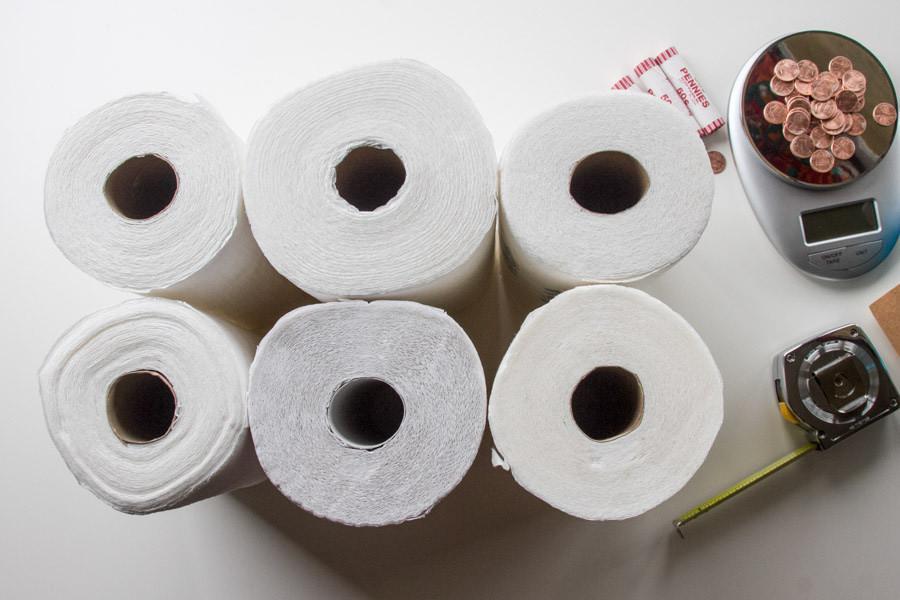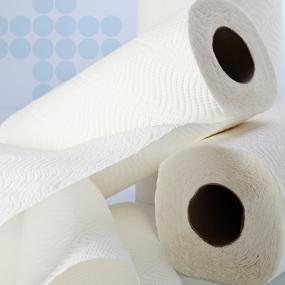The first image is the image on the left, the second image is the image on the right. Analyze the images presented: Is the assertion "Two paper towel rolls lie on a surface in one of the images." valid? Answer yes or no. No. The first image is the image on the left, the second image is the image on the right. Given the left and right images, does the statement "An image features some neatly stacked rolls of paper towels." hold true? Answer yes or no. No. 